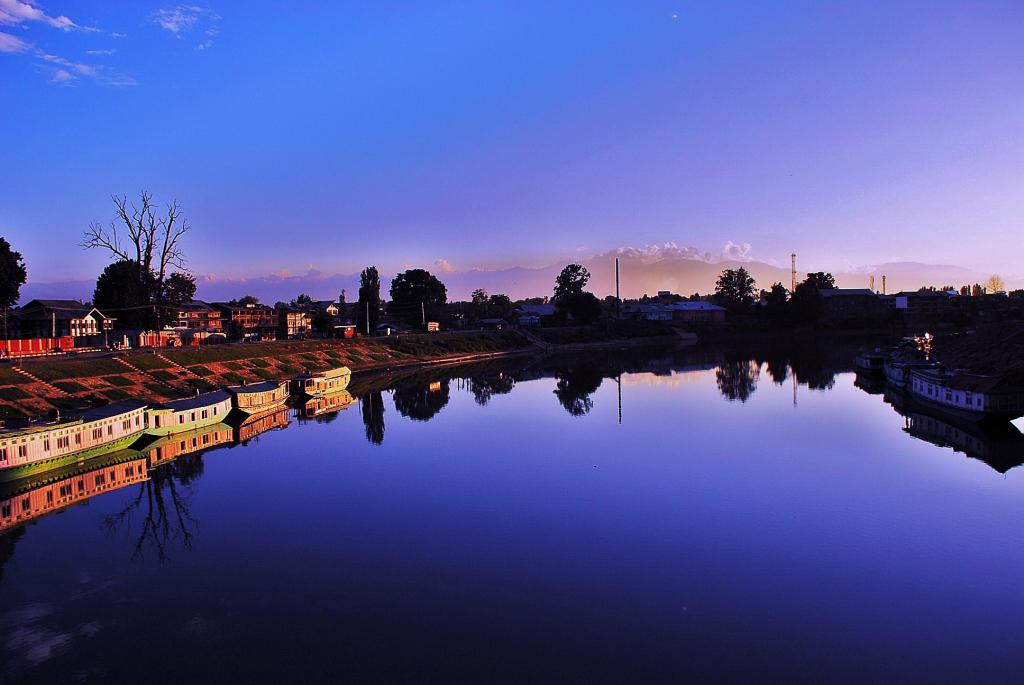What type of vehicles can be seen in the image? There are boats on the water in the image. What structures are visible in the image? There are buildings visible in the image. What type of vegetation is present in the image? There are trees in the image. What natural features can be seen in the background of the image? There are mountains in the background of the image. What is visible in the sky in the image? The sky is visible in the background of the image. What type of alarm can be heard going off in the image? There is no alarm present in the image, as it is a still image and cannot produce sound. Can you see a beetle crawling on the trees in the image? There is no beetle visible in the image; only boats, buildings, trees, mountains, and the sky are present. 